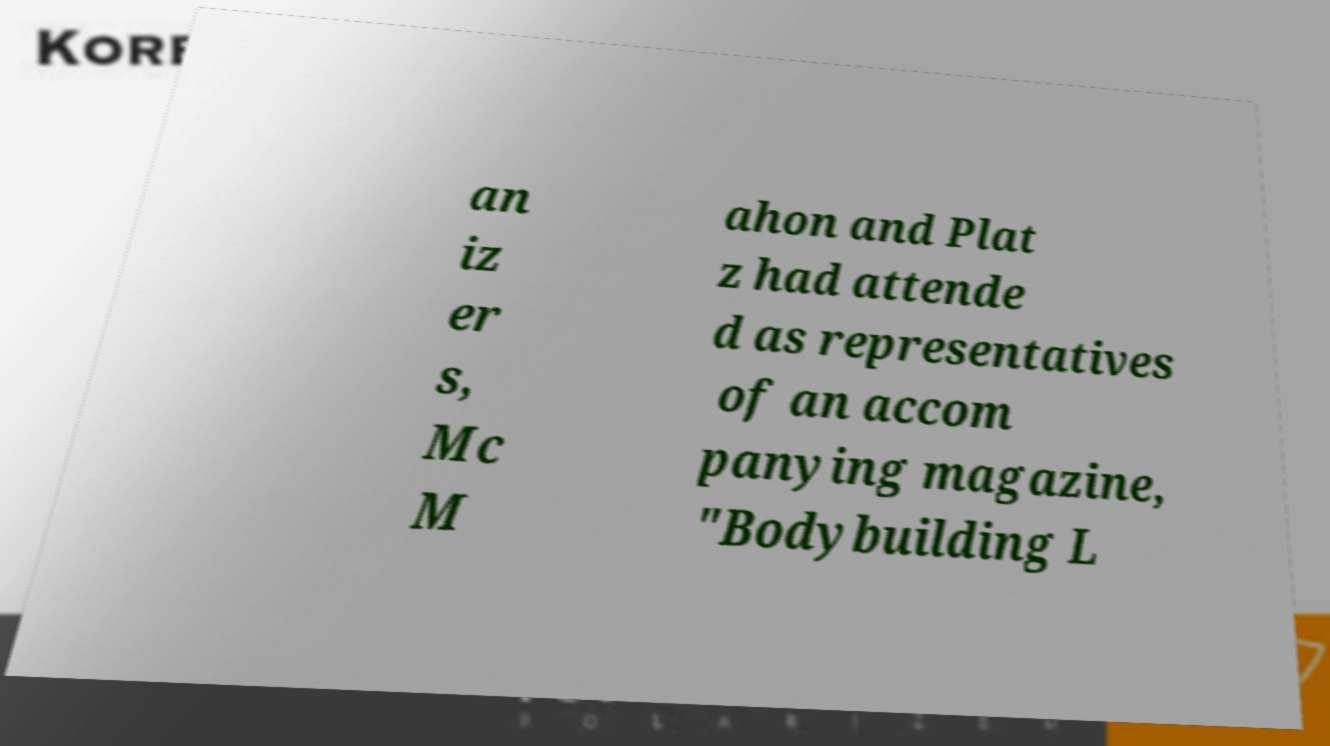What messages or text are displayed in this image? I need them in a readable, typed format. an iz er s, Mc M ahon and Plat z had attende d as representatives of an accom panying magazine, "Bodybuilding L 